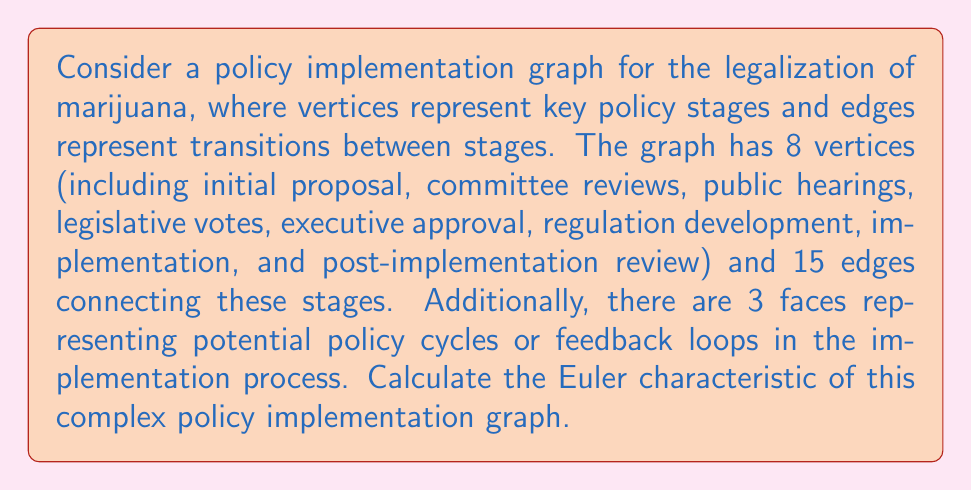Solve this math problem. To calculate the Euler characteristic of the given policy implementation graph, we'll use the formula:

$$\chi = V - E + F$$

Where:
$\chi$ = Euler characteristic
$V$ = Number of vertices
$E$ = Number of edges
$F$ = Number of faces

Given:
$V = 8$ (policy stages)
$E = 15$ (transitions between stages)
$F = 3$ (policy cycles or feedback loops)

Let's substitute these values into the formula:

$$\chi = 8 - 15 + 3$$

Now, let's perform the calculation:

$$\chi = -4$$

The negative Euler characteristic indicates that this policy implementation graph has a complex structure with multiple connections and feedback loops, which is typical for intricate policy processes like marijuana legalization.
Answer: $\chi = -4$ 